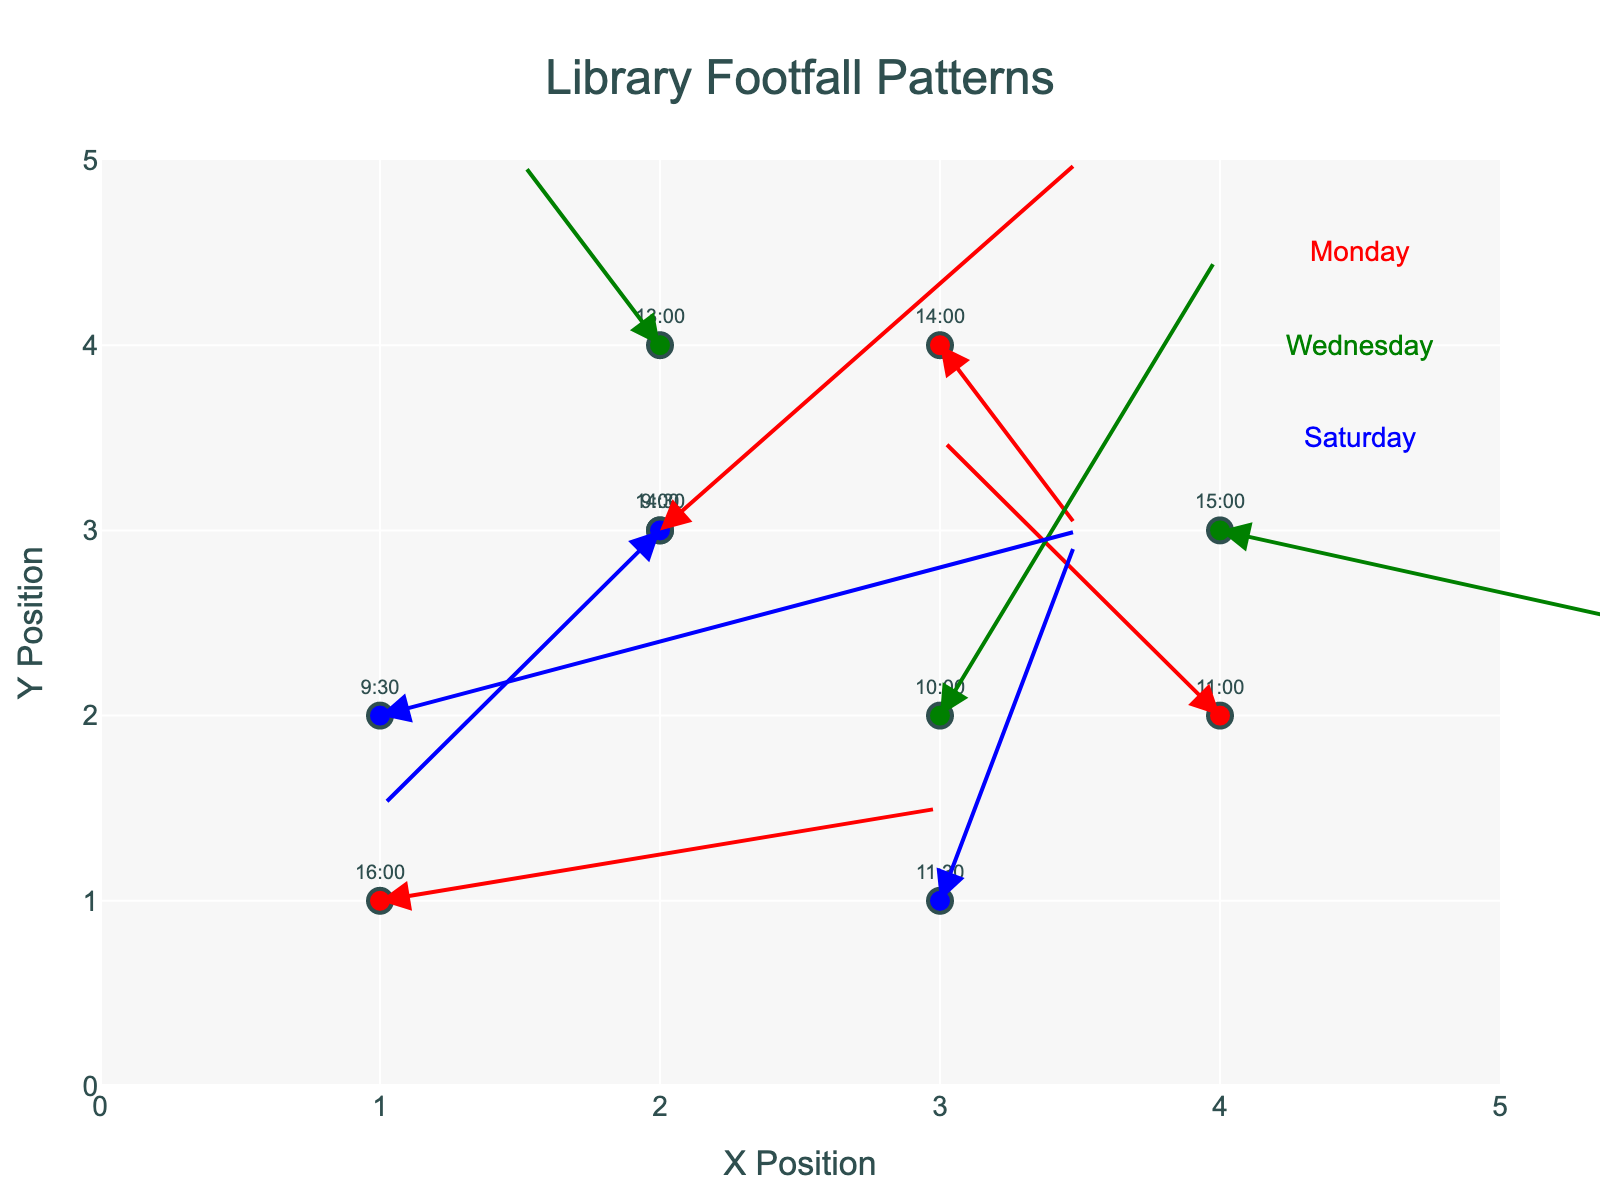What is the title of the plot? The title is given at the top of the plot, written as "Library Footfall Patterns".
Answer: Library Footfall Patterns What colors represent each day in the plot? You can see the different colored markers for each day: Monday is red, Wednesday is green, and Saturday is blue.
Answer: Red, Green, Blue How many footfall data points are there for Wednesday? Count the number of markers labeled as Wednesday on the plot. There are 3 such points.
Answer: 3 Which time has the highest footfall on Saturday? Look for the longest arrow or the data point that shows the largest movement direction on Saturday. 9:30 has an arrow with magnitude (sqrt(2.5^2 + 1.0^2)) which is approximately 2.69, the highest for Saturday.
Answer: 9:30 Which day shows the most significant movement in the X direction? Calculate the absolute value of the U (X-direction movement) for each point and identify the largest value among all days; Monday has U=2.0 at 16:00, the highest in the dataset.
Answer: Monday What is the start position and end position of the footfall data point at 11:00 on Monday? Identify the start position (X=4, Y=2) and compute the end position using the U and V values: (4 - 1.0, 2 + 1.5) = (3, 3.5).
Answer: Start: (4, 2), End: (3, 3.5) What pattern is visible for footfall movement on Saturday? Analyze the markers and arrows for Saturday. Both the footfall increases and decreases, with starting points at bottom left moving to the top right and then returning, indicating morning to mid-afternoon activities and a decrease in the afternoon.
Answer: Mixed increase and decrease in footfall over the day What is the average footfall magnitude for all days combined? Calculate the magnitude for each arrow using sqrt(U^2 + V^2) for all data points, sum them and divide by the total number of points (10). sqrt(2.5^2 + 1^2) + sqrt(0.5^2 + 1.5^2) + ... + sqrt(-1.0^2 + -1.5^2) / 10. The sum of magnitudes is around 17.85.
Answer: Approximately 1.79 